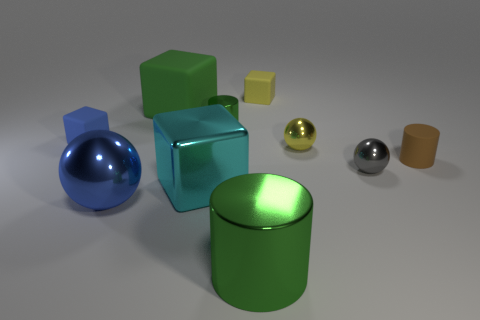Does the small rubber cylinder have the same color as the big matte cube?
Ensure brevity in your answer.  No. What shape is the big metallic object that is the same color as the large rubber thing?
Your answer should be compact. Cylinder. What color is the object that is both to the left of the green rubber object and in front of the blue block?
Keep it short and to the point. Blue. Do the cube that is left of the blue ball and the large cylinder have the same size?
Ensure brevity in your answer.  No. Are there more cyan shiny cubes left of the large rubber object than big balls?
Offer a very short reply. No. Is the shape of the tiny gray shiny thing the same as the brown matte object?
Your answer should be very brief. No. The cyan object has what size?
Offer a terse response. Large. Are there more small matte objects left of the small matte cylinder than brown matte things that are in front of the blue metal sphere?
Offer a terse response. Yes. Are there any big green cylinders left of the metal cube?
Your answer should be very brief. No. Are there any gray balls of the same size as the cyan shiny cube?
Your answer should be very brief. No. 